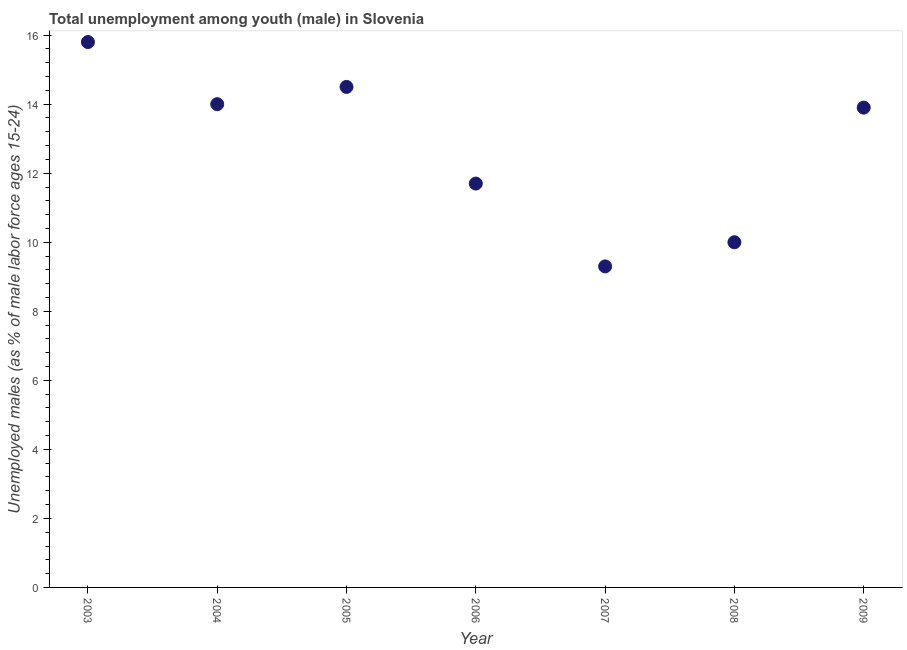What is the unemployed male youth population in 2009?
Your answer should be compact. 13.9. Across all years, what is the maximum unemployed male youth population?
Your answer should be compact. 15.8. Across all years, what is the minimum unemployed male youth population?
Offer a terse response. 9.3. In which year was the unemployed male youth population maximum?
Provide a short and direct response. 2003. What is the sum of the unemployed male youth population?
Your answer should be very brief. 89.2. What is the average unemployed male youth population per year?
Your answer should be very brief. 12.74. What is the median unemployed male youth population?
Provide a succinct answer. 13.9. In how many years, is the unemployed male youth population greater than 4.8 %?
Offer a very short reply. 7. Do a majority of the years between 2007 and 2008 (inclusive) have unemployed male youth population greater than 12 %?
Ensure brevity in your answer.  No. What is the ratio of the unemployed male youth population in 2004 to that in 2007?
Keep it short and to the point. 1.51. Is the unemployed male youth population in 2003 less than that in 2005?
Your answer should be compact. No. What is the difference between the highest and the second highest unemployed male youth population?
Offer a very short reply. 1.3. What is the difference between the highest and the lowest unemployed male youth population?
Provide a succinct answer. 6.5. Does the graph contain any zero values?
Provide a succinct answer. No. Does the graph contain grids?
Provide a short and direct response. No. What is the title of the graph?
Provide a succinct answer. Total unemployment among youth (male) in Slovenia. What is the label or title of the Y-axis?
Make the answer very short. Unemployed males (as % of male labor force ages 15-24). What is the Unemployed males (as % of male labor force ages 15-24) in 2003?
Offer a very short reply. 15.8. What is the Unemployed males (as % of male labor force ages 15-24) in 2004?
Ensure brevity in your answer.  14. What is the Unemployed males (as % of male labor force ages 15-24) in 2006?
Offer a terse response. 11.7. What is the Unemployed males (as % of male labor force ages 15-24) in 2007?
Your response must be concise. 9.3. What is the Unemployed males (as % of male labor force ages 15-24) in 2009?
Ensure brevity in your answer.  13.9. What is the difference between the Unemployed males (as % of male labor force ages 15-24) in 2003 and 2004?
Your answer should be compact. 1.8. What is the difference between the Unemployed males (as % of male labor force ages 15-24) in 2003 and 2005?
Give a very brief answer. 1.3. What is the difference between the Unemployed males (as % of male labor force ages 15-24) in 2003 and 2006?
Your answer should be compact. 4.1. What is the difference between the Unemployed males (as % of male labor force ages 15-24) in 2003 and 2008?
Offer a terse response. 5.8. What is the difference between the Unemployed males (as % of male labor force ages 15-24) in 2003 and 2009?
Your response must be concise. 1.9. What is the difference between the Unemployed males (as % of male labor force ages 15-24) in 2004 and 2006?
Provide a short and direct response. 2.3. What is the difference between the Unemployed males (as % of male labor force ages 15-24) in 2004 and 2008?
Your response must be concise. 4. What is the difference between the Unemployed males (as % of male labor force ages 15-24) in 2004 and 2009?
Offer a terse response. 0.1. What is the difference between the Unemployed males (as % of male labor force ages 15-24) in 2005 and 2006?
Your answer should be compact. 2.8. What is the difference between the Unemployed males (as % of male labor force ages 15-24) in 2005 and 2008?
Provide a short and direct response. 4.5. What is the difference between the Unemployed males (as % of male labor force ages 15-24) in 2008 and 2009?
Your answer should be very brief. -3.9. What is the ratio of the Unemployed males (as % of male labor force ages 15-24) in 2003 to that in 2004?
Offer a terse response. 1.13. What is the ratio of the Unemployed males (as % of male labor force ages 15-24) in 2003 to that in 2005?
Ensure brevity in your answer.  1.09. What is the ratio of the Unemployed males (as % of male labor force ages 15-24) in 2003 to that in 2006?
Your response must be concise. 1.35. What is the ratio of the Unemployed males (as % of male labor force ages 15-24) in 2003 to that in 2007?
Ensure brevity in your answer.  1.7. What is the ratio of the Unemployed males (as % of male labor force ages 15-24) in 2003 to that in 2008?
Your answer should be compact. 1.58. What is the ratio of the Unemployed males (as % of male labor force ages 15-24) in 2003 to that in 2009?
Keep it short and to the point. 1.14. What is the ratio of the Unemployed males (as % of male labor force ages 15-24) in 2004 to that in 2005?
Provide a short and direct response. 0.97. What is the ratio of the Unemployed males (as % of male labor force ages 15-24) in 2004 to that in 2006?
Your answer should be very brief. 1.2. What is the ratio of the Unemployed males (as % of male labor force ages 15-24) in 2004 to that in 2007?
Offer a terse response. 1.5. What is the ratio of the Unemployed males (as % of male labor force ages 15-24) in 2004 to that in 2008?
Offer a very short reply. 1.4. What is the ratio of the Unemployed males (as % of male labor force ages 15-24) in 2004 to that in 2009?
Your answer should be very brief. 1.01. What is the ratio of the Unemployed males (as % of male labor force ages 15-24) in 2005 to that in 2006?
Your response must be concise. 1.24. What is the ratio of the Unemployed males (as % of male labor force ages 15-24) in 2005 to that in 2007?
Make the answer very short. 1.56. What is the ratio of the Unemployed males (as % of male labor force ages 15-24) in 2005 to that in 2008?
Provide a short and direct response. 1.45. What is the ratio of the Unemployed males (as % of male labor force ages 15-24) in 2005 to that in 2009?
Ensure brevity in your answer.  1.04. What is the ratio of the Unemployed males (as % of male labor force ages 15-24) in 2006 to that in 2007?
Make the answer very short. 1.26. What is the ratio of the Unemployed males (as % of male labor force ages 15-24) in 2006 to that in 2008?
Your answer should be very brief. 1.17. What is the ratio of the Unemployed males (as % of male labor force ages 15-24) in 2006 to that in 2009?
Your answer should be compact. 0.84. What is the ratio of the Unemployed males (as % of male labor force ages 15-24) in 2007 to that in 2009?
Provide a short and direct response. 0.67. What is the ratio of the Unemployed males (as % of male labor force ages 15-24) in 2008 to that in 2009?
Keep it short and to the point. 0.72. 